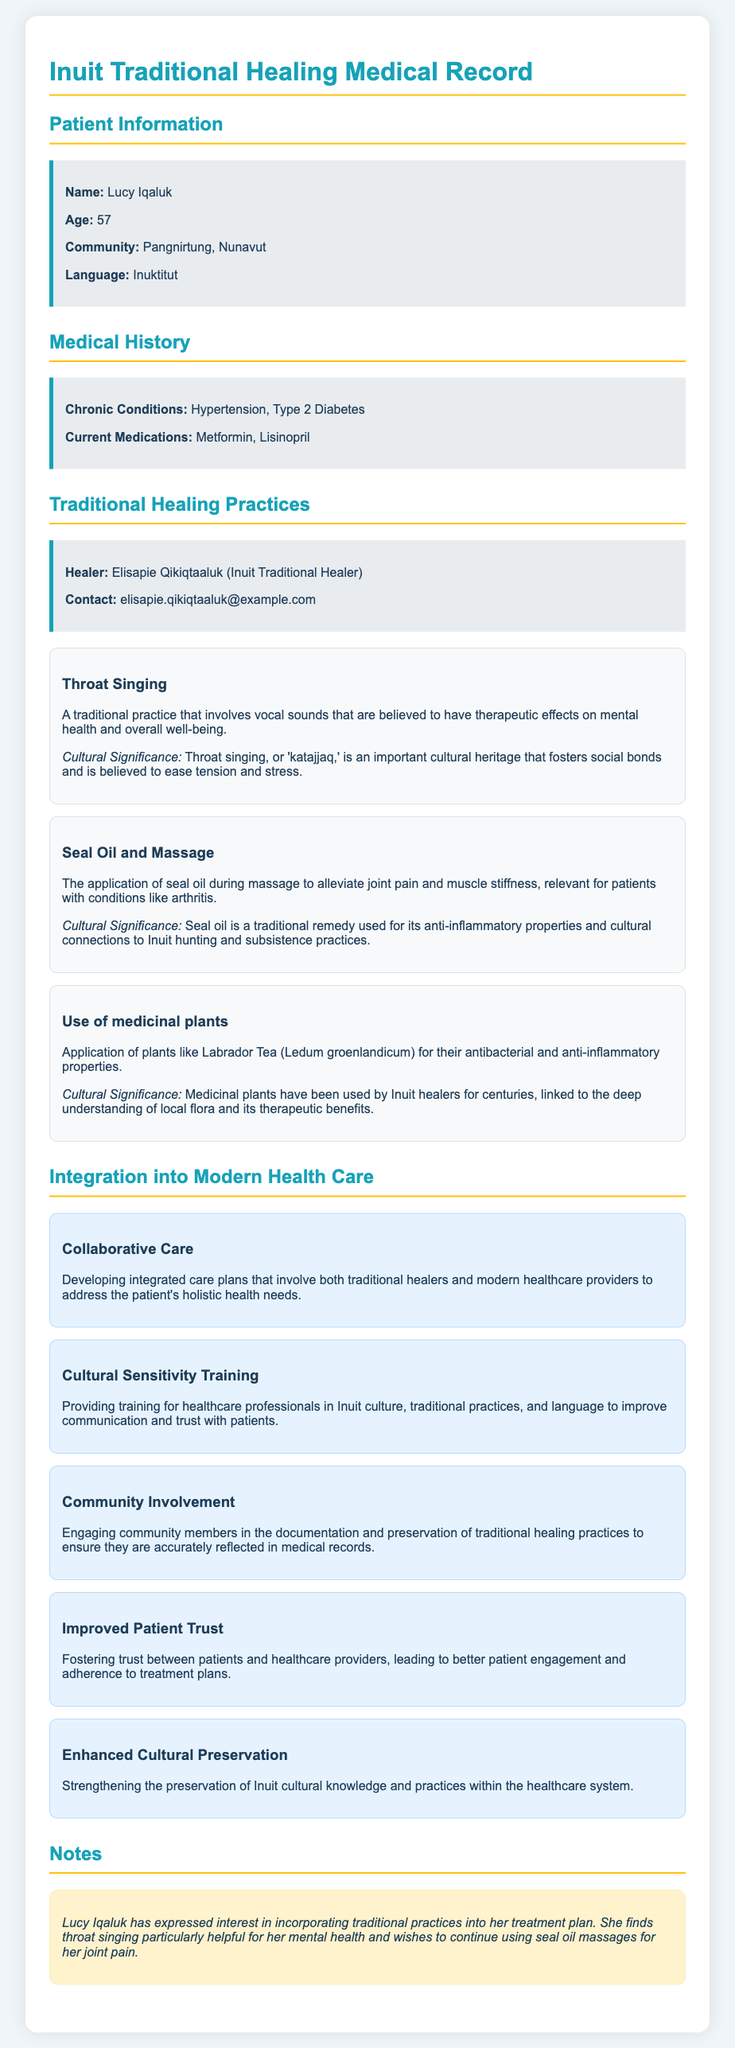what is the name of the patient? The document lists the patient's name as Lucy Iqaluk.
Answer: Lucy Iqaluk how old is Lucy Iqaluk? The document provides Lucy Iqaluk's age, which is mentioned explicitly.
Answer: 57 what are Lucy Iqaluk's chronic conditions? The document specifies chronic conditions in the medical history section.
Answer: Hypertension, Type 2 Diabetes who is the traditional healer mentioned? The healer's name is provided in the Traditional Healing Practices section.
Answer: Elisapie Qikiqtaaluk what is one therapeutic effect of throat singing? The document describes therapeutic effects linked to throat singing.
Answer: Mental health what type of oil is used in the massage? The document states the specific oil used in traditional healing practices.
Answer: Seal oil what is an example of a medicinal plant mentioned? The document lists a specific medicinal plant used by Inuit healers.
Answer: Labrador Tea how does collaborative care benefit patients? This question requires reasoning based on information about integration into modern healthcare.
Answer: Holistic health needs what practice is used to alleviate joint pain? The document specifically mentions a practice for alleviating joint pain.
Answer: Seal Oil and Massage what cultural practice enhances trust in healthcare? The document discusses practices that contribute to better patient-provider relationships.
Answer: Cultural Sensitivity Training 